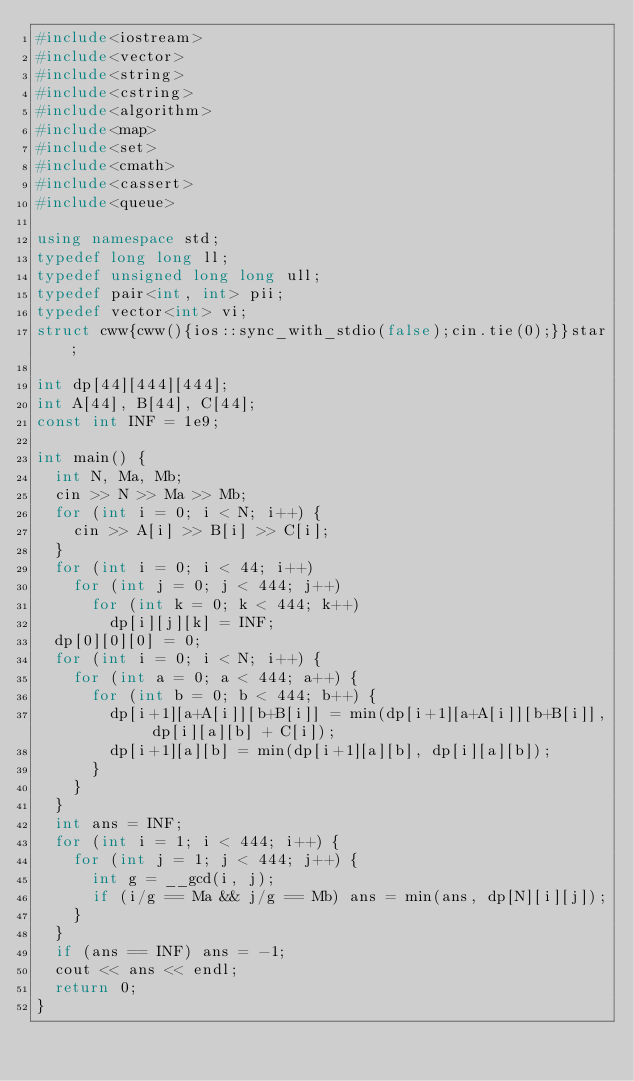<code> <loc_0><loc_0><loc_500><loc_500><_C++_>#include<iostream>
#include<vector>
#include<string>
#include<cstring>
#include<algorithm>
#include<map>
#include<set>
#include<cmath>
#include<cassert>
#include<queue>

using namespace std;
typedef long long ll;
typedef unsigned long long ull;
typedef pair<int, int> pii;
typedef vector<int> vi;
struct cww{cww(){ios::sync_with_stdio(false);cin.tie(0);}}star;

int dp[44][444][444];
int A[44], B[44], C[44];
const int INF = 1e9;

int main() {
	int N, Ma, Mb;
	cin >> N >> Ma >> Mb;
	for (int i = 0; i < N; i++) {
		cin >> A[i] >> B[i] >> C[i];
	}
	for (int i = 0; i < 44; i++)
		for (int j = 0; j < 444; j++)
			for (int k = 0; k < 444; k++)
				dp[i][j][k] = INF;
	dp[0][0][0] = 0;
	for (int i = 0; i < N; i++) {
		for (int a = 0; a < 444; a++) {
			for (int b = 0; b < 444; b++) {
				dp[i+1][a+A[i]][b+B[i]] = min(dp[i+1][a+A[i]][b+B[i]], dp[i][a][b] + C[i]);
				dp[i+1][a][b] = min(dp[i+1][a][b], dp[i][a][b]);
			}
		}
	}
	int ans = INF;
	for (int i = 1; i < 444; i++) {
		for (int j = 1; j < 444; j++) {
			int g = __gcd(i, j);
			if (i/g == Ma && j/g == Mb) ans = min(ans, dp[N][i][j]);
		}
	}
	if (ans == INF) ans = -1;
	cout << ans << endl;
	return 0;
}
</code> 